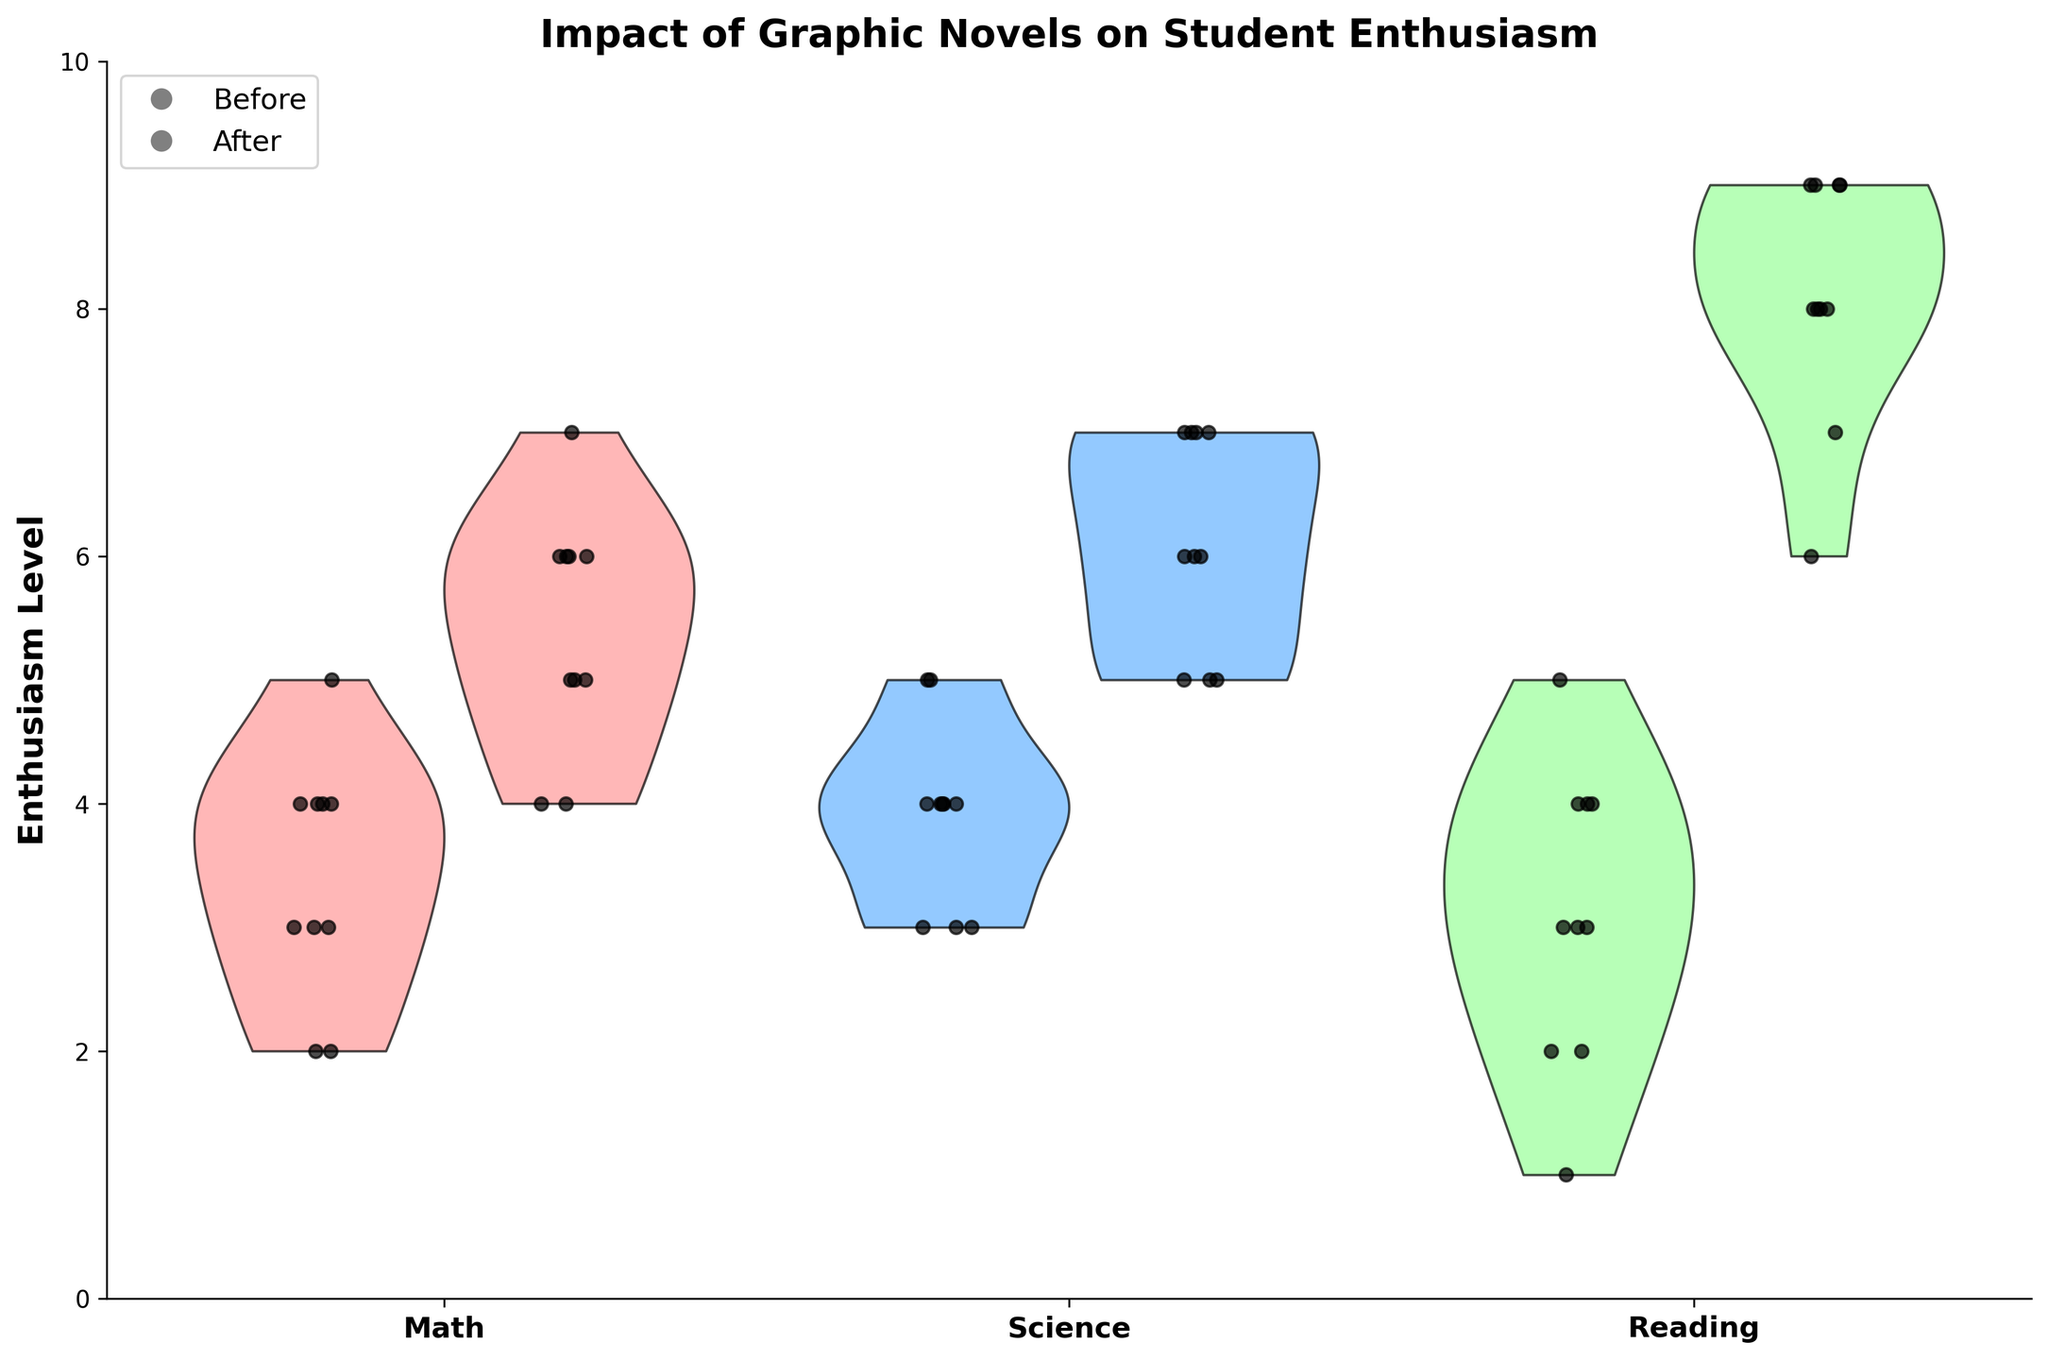What is the title of the figure? The title is usually located at the top of the plot, often in bold and slightly larger text. In this case, it reads *"Impact of Graphic Novels on Student Enthusiasm"*.
Answer: Impact of Graphic Novels on Student Enthusiasm What are the subjects covered in the study? The x-axis labels typically represent the different categories or groups of data. In this figure, the x-axis lists three subjects: Math, Science, and Reading.
Answer: Math, Science, and Reading Which enthusiasm levels are shown on the y-axis? The y-axis in the plot indicates the range of enthusiasm levels represented by numbers from 0 to 10.
Answer: 0 to 10 What does the legend indicate in the plot? The legend in the plot shows two markers labeled Before and After. These markers help distinguish between the data points representing enthusiasm levels before and after introducing graphic novels.
Answer: Before and After Which subject showed the greatest increase in enthusiasm after introducing graphic novels? By comparing the data points and violins for each subject, we can see the largest difference in positions between "Before" and "After" in the Reading subject.
Answer: Reading How does the children's enthusiasm in Math before introducing graphic novels compare to after? Compare the location of jittered points and the spread of the violins for Math. The violin and points for "After" are shifted higher than those for "Before," indicating an increase.
Answer: Increased What do the points within the violins represent? The jittered points within the violins represent individual children's enthusiasm levels, providing specific values within the distribution.
Answer: Individual children's enthusiasm levels What can be said about the distribution of enthusiasm levels in Reading before introducing graphic novels? The distribution for Reading before shows a tight spread of points lower in the enthusiasm scale, indicating generally low enthusiasm.
Answer: Generally low enthusiasm Between Math and Science, which subject's enthusiasm level changed more dramatically after introducing graphic novels? Comparing the shift in the positions of points and violins from "Before" to "After" for both subjects, Science shows a larger shift.
Answer: Science For Science, what is a noticeable difference between the distributions of "Before" and "After"? There is a noticeable upward shift and a wider spread of the points in the "After" distribution compared to the "Before," indicating higher enthusiasm levels and more variability.
Answer: Higher and more variable enthusiasm levels 